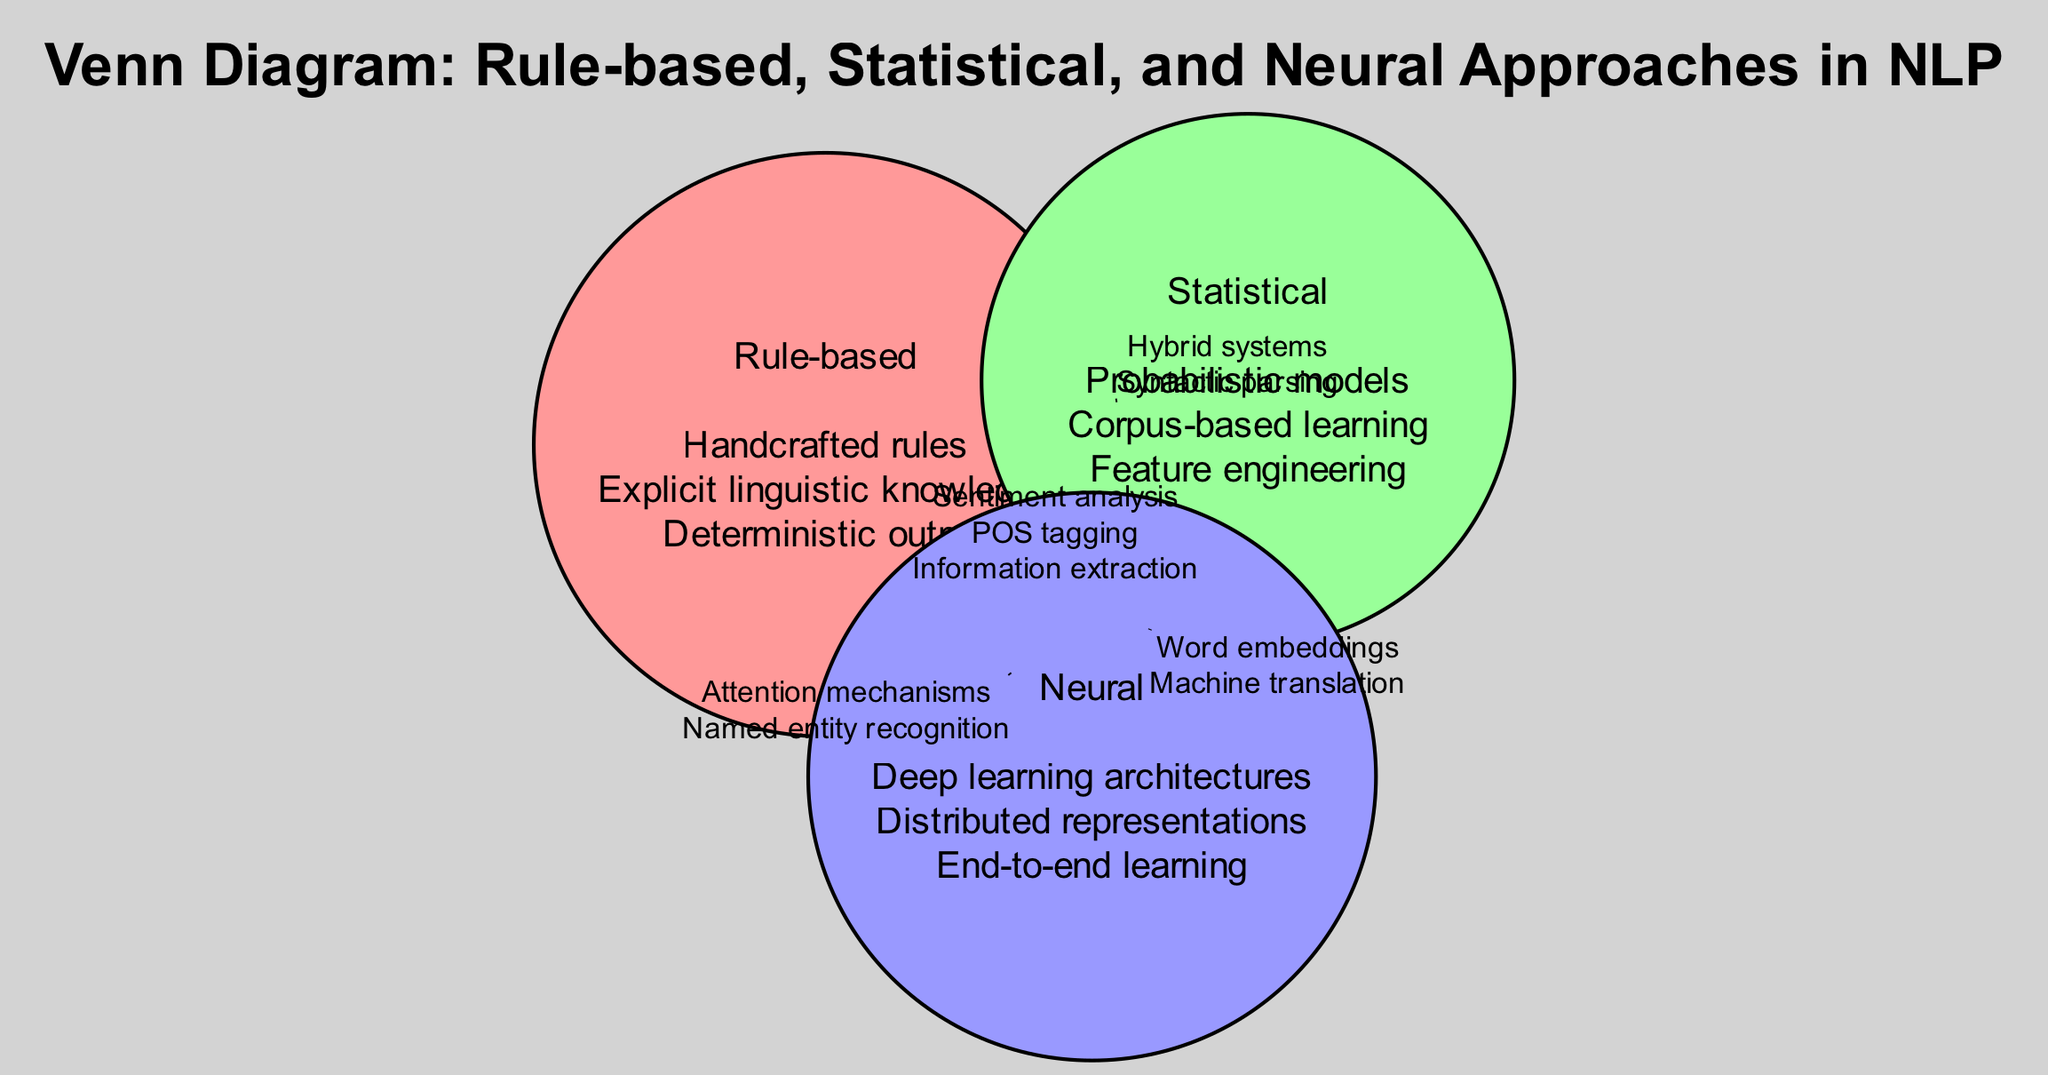What features are exclusive to the Rule-based approach? The features listed under the Rule-based circle are "Handcrafted rules," "Explicit linguistic knowledge," and "Deterministic output." These features are not mentioned in other approaches.
Answer: Handcrafted rules, Explicit linguistic knowledge, Deterministic output How many features are shared between the Statistical and Neural approaches? The intersection between the Statistical and Neural circles contains two features: "Word embeddings" and "Machine translation," which is found in that specific overlap.
Answer: 2 What is the common task across all three approaches? The features listed in the intersection of all three circles include "Sentiment analysis," "POS tagging," and "Information extraction," indicating they are common to all.
Answer: Sentiment analysis, POS tagging, Information extraction Which method involves "Hybrid systems"? The feature "Hybrid systems" appears in the intersection of the Rule-based and Statistical circles. Thus, it is associated with both of these approaches.
Answer: Rule-based, Statistical What type of learning characterizes the Neural approach? The Neural approach is characterized by features such as "Deep learning architectures," "Distributed representations," and "End-to-end learning," indicating its reliance on these types of learning.
Answer: Deep learning architectures, Distributed representations, End-to-end learning Which two approaches share "Attention mechanisms"? The feature "Attention mechanisms" is found in the intersection of the Rule-based and Neural approaches, indicating that both utilize this feature in their methodologies.
Answer: Rule-based, Neural What is a unique feature of Statistical methods not found in other approaches? The feature "Probabilistic models" only appears in the Statistical circle and is not mentioned in the other approaches, making it unique to Statistical methods.
Answer: Probabilistic models How many total features are listed for the Neural approach? There are three features listed under the Neural approach: "Deep learning architectures," "Distributed representations," and "End-to-end learning."
Answer: 3 What task is associated exclusively with Rule-based but not Statistical or Neural? The feature "Handcrafted rules" is unique to the Rule-based circle and does not appear in the other two approaches. Hence, it signifies an exclusive task associated with Rule-based methods.
Answer: Handcrafted rules 